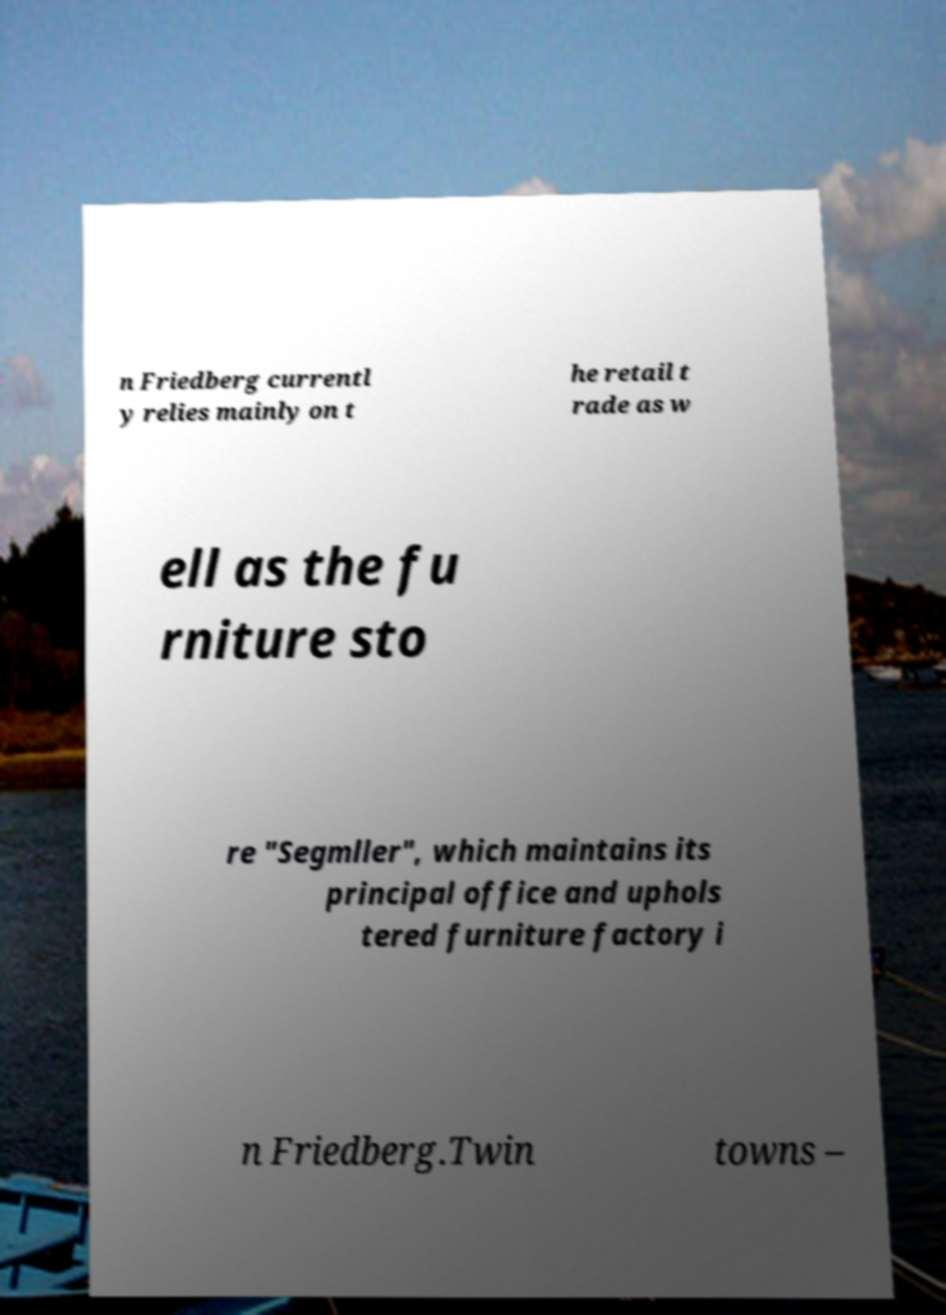Please read and relay the text visible in this image. What does it say? n Friedberg currentl y relies mainly on t he retail t rade as w ell as the fu rniture sto re "Segmller", which maintains its principal office and uphols tered furniture factory i n Friedberg.Twin towns – 